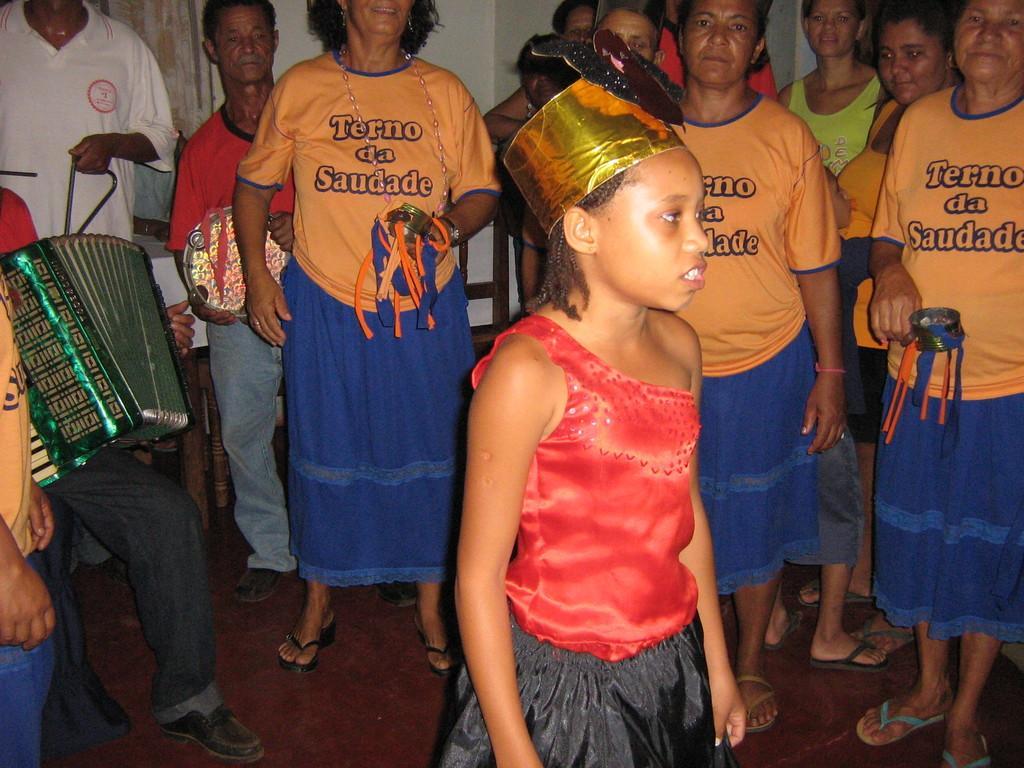How would you summarize this image in a sentence or two? There are group of people wearing similar costume and in the front a kid is standing and she is wearing red and black dress,behind the the kid there is a person sitting playing a musical instrument,in the background there is a wall. 